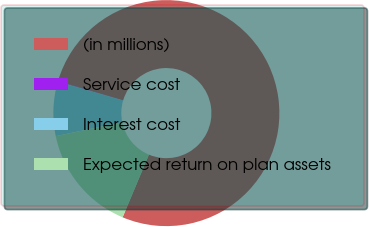Convert chart to OTSL. <chart><loc_0><loc_0><loc_500><loc_500><pie_chart><fcel>(in millions)<fcel>Service cost<fcel>Interest cost<fcel>Expected return on plan assets<nl><fcel>76.76%<fcel>0.08%<fcel>7.75%<fcel>15.41%<nl></chart> 